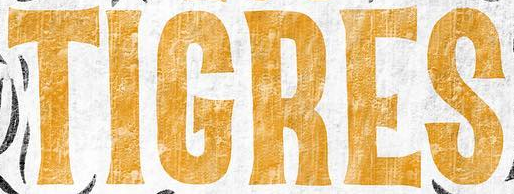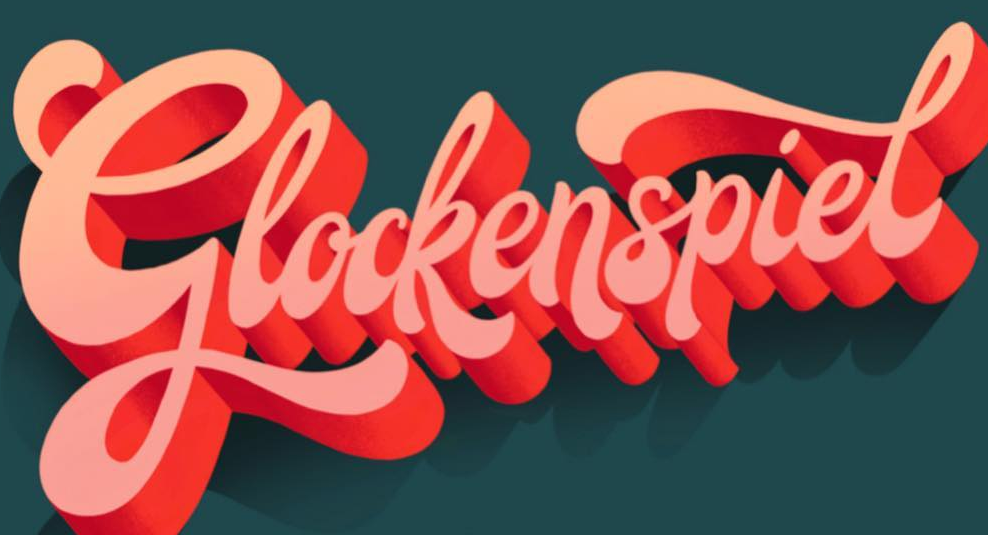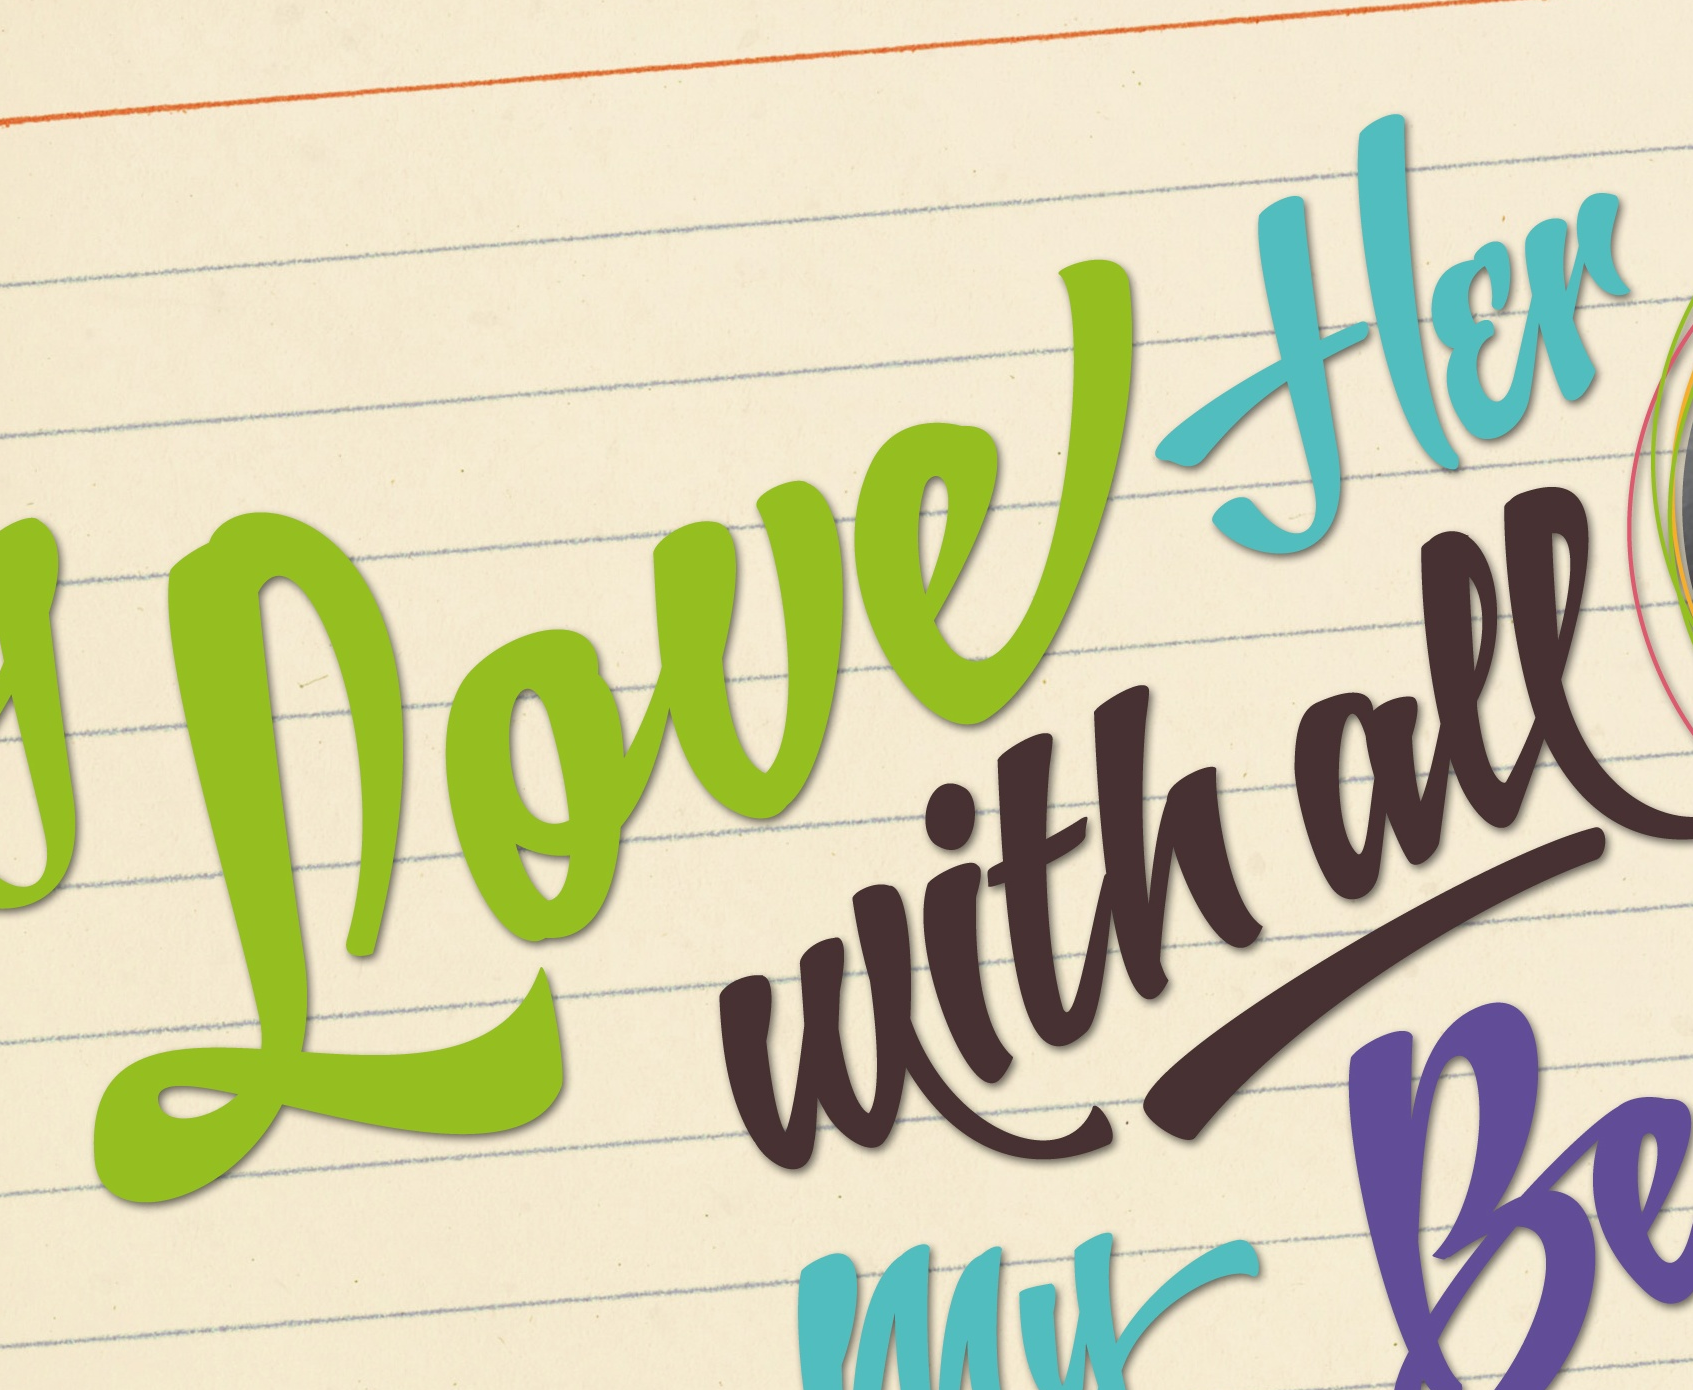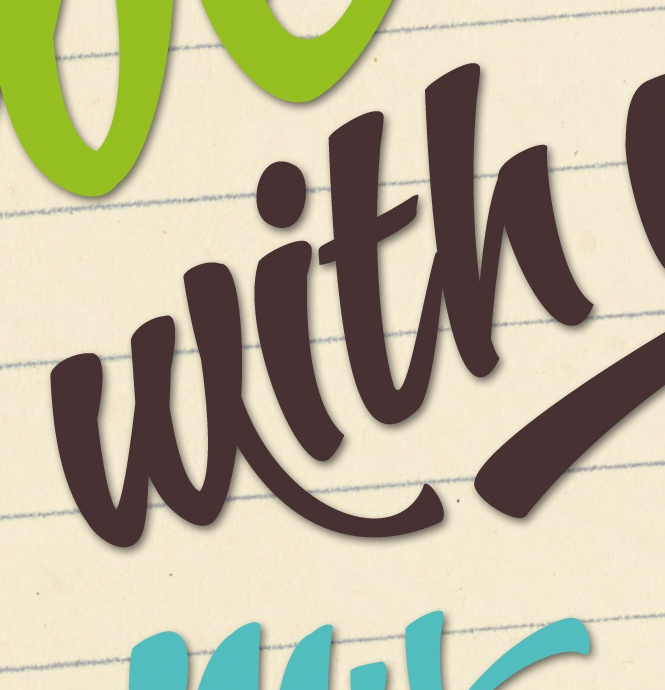Identify the words shown in these images in order, separated by a semicolon. TIGRES; Glockenspiel; Loueflɛr; with 